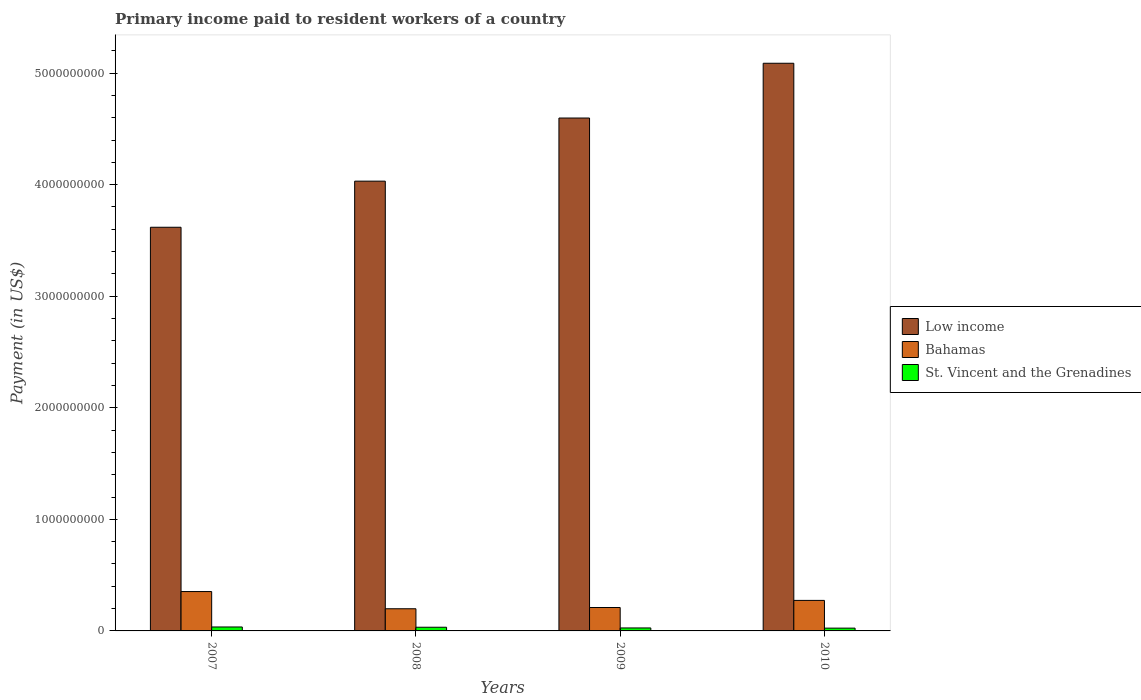How many different coloured bars are there?
Provide a short and direct response. 3. Are the number of bars per tick equal to the number of legend labels?
Your answer should be compact. Yes. Are the number of bars on each tick of the X-axis equal?
Provide a short and direct response. Yes. How many bars are there on the 4th tick from the left?
Provide a succinct answer. 3. What is the label of the 4th group of bars from the left?
Ensure brevity in your answer.  2010. In how many cases, is the number of bars for a given year not equal to the number of legend labels?
Provide a succinct answer. 0. What is the amount paid to workers in Low income in 2008?
Offer a terse response. 4.03e+09. Across all years, what is the maximum amount paid to workers in Low income?
Make the answer very short. 5.09e+09. Across all years, what is the minimum amount paid to workers in Bahamas?
Offer a terse response. 1.99e+08. In which year was the amount paid to workers in Bahamas maximum?
Provide a short and direct response. 2007. What is the total amount paid to workers in Bahamas in the graph?
Provide a short and direct response. 1.04e+09. What is the difference between the amount paid to workers in Bahamas in 2007 and that in 2010?
Your answer should be compact. 7.92e+07. What is the difference between the amount paid to workers in Bahamas in 2007 and the amount paid to workers in Low income in 2010?
Provide a succinct answer. -4.74e+09. What is the average amount paid to workers in St. Vincent and the Grenadines per year?
Keep it short and to the point. 3.00e+07. In the year 2009, what is the difference between the amount paid to workers in St. Vincent and the Grenadines and amount paid to workers in Bahamas?
Provide a succinct answer. -1.83e+08. In how many years, is the amount paid to workers in St. Vincent and the Grenadines greater than 1600000000 US$?
Provide a short and direct response. 0. What is the ratio of the amount paid to workers in St. Vincent and the Grenadines in 2007 to that in 2010?
Your response must be concise. 1.42. Is the difference between the amount paid to workers in St. Vincent and the Grenadines in 2007 and 2008 greater than the difference between the amount paid to workers in Bahamas in 2007 and 2008?
Give a very brief answer. No. What is the difference between the highest and the second highest amount paid to workers in Low income?
Offer a terse response. 4.91e+08. What is the difference between the highest and the lowest amount paid to workers in St. Vincent and the Grenadines?
Your answer should be compact. 1.05e+07. In how many years, is the amount paid to workers in Low income greater than the average amount paid to workers in Low income taken over all years?
Provide a short and direct response. 2. Is the sum of the amount paid to workers in Bahamas in 2007 and 2008 greater than the maximum amount paid to workers in Low income across all years?
Provide a short and direct response. No. Are all the bars in the graph horizontal?
Provide a short and direct response. No. How many years are there in the graph?
Offer a very short reply. 4. Are the values on the major ticks of Y-axis written in scientific E-notation?
Keep it short and to the point. No. Where does the legend appear in the graph?
Keep it short and to the point. Center right. How many legend labels are there?
Offer a very short reply. 3. What is the title of the graph?
Ensure brevity in your answer.  Primary income paid to resident workers of a country. What is the label or title of the Y-axis?
Offer a terse response. Payment (in US$). What is the Payment (in US$) in Low income in 2007?
Your answer should be very brief. 3.62e+09. What is the Payment (in US$) in Bahamas in 2007?
Give a very brief answer. 3.53e+08. What is the Payment (in US$) in St. Vincent and the Grenadines in 2007?
Offer a terse response. 3.54e+07. What is the Payment (in US$) in Low income in 2008?
Offer a very short reply. 4.03e+09. What is the Payment (in US$) in Bahamas in 2008?
Provide a succinct answer. 1.99e+08. What is the Payment (in US$) of St. Vincent and the Grenadines in 2008?
Provide a short and direct response. 3.30e+07. What is the Payment (in US$) of Low income in 2009?
Ensure brevity in your answer.  4.60e+09. What is the Payment (in US$) in Bahamas in 2009?
Your response must be concise. 2.10e+08. What is the Payment (in US$) of St. Vincent and the Grenadines in 2009?
Your answer should be compact. 2.67e+07. What is the Payment (in US$) in Low income in 2010?
Provide a succinct answer. 5.09e+09. What is the Payment (in US$) of Bahamas in 2010?
Provide a succinct answer. 2.74e+08. What is the Payment (in US$) of St. Vincent and the Grenadines in 2010?
Your answer should be very brief. 2.49e+07. Across all years, what is the maximum Payment (in US$) in Low income?
Your answer should be very brief. 5.09e+09. Across all years, what is the maximum Payment (in US$) of Bahamas?
Your response must be concise. 3.53e+08. Across all years, what is the maximum Payment (in US$) in St. Vincent and the Grenadines?
Make the answer very short. 3.54e+07. Across all years, what is the minimum Payment (in US$) of Low income?
Your response must be concise. 3.62e+09. Across all years, what is the minimum Payment (in US$) in Bahamas?
Provide a succinct answer. 1.99e+08. Across all years, what is the minimum Payment (in US$) of St. Vincent and the Grenadines?
Give a very brief answer. 2.49e+07. What is the total Payment (in US$) of Low income in the graph?
Make the answer very short. 1.73e+1. What is the total Payment (in US$) of Bahamas in the graph?
Ensure brevity in your answer.  1.04e+09. What is the total Payment (in US$) in St. Vincent and the Grenadines in the graph?
Provide a succinct answer. 1.20e+08. What is the difference between the Payment (in US$) in Low income in 2007 and that in 2008?
Ensure brevity in your answer.  -4.13e+08. What is the difference between the Payment (in US$) of Bahamas in 2007 and that in 2008?
Make the answer very short. 1.54e+08. What is the difference between the Payment (in US$) of St. Vincent and the Grenadines in 2007 and that in 2008?
Give a very brief answer. 2.46e+06. What is the difference between the Payment (in US$) of Low income in 2007 and that in 2009?
Give a very brief answer. -9.79e+08. What is the difference between the Payment (in US$) in Bahamas in 2007 and that in 2009?
Provide a succinct answer. 1.43e+08. What is the difference between the Payment (in US$) of St. Vincent and the Grenadines in 2007 and that in 2009?
Your answer should be very brief. 8.72e+06. What is the difference between the Payment (in US$) in Low income in 2007 and that in 2010?
Offer a terse response. -1.47e+09. What is the difference between the Payment (in US$) of Bahamas in 2007 and that in 2010?
Your answer should be very brief. 7.92e+07. What is the difference between the Payment (in US$) in St. Vincent and the Grenadines in 2007 and that in 2010?
Offer a terse response. 1.05e+07. What is the difference between the Payment (in US$) in Low income in 2008 and that in 2009?
Give a very brief answer. -5.66e+08. What is the difference between the Payment (in US$) in Bahamas in 2008 and that in 2009?
Keep it short and to the point. -1.12e+07. What is the difference between the Payment (in US$) of St. Vincent and the Grenadines in 2008 and that in 2009?
Your answer should be very brief. 6.26e+06. What is the difference between the Payment (in US$) in Low income in 2008 and that in 2010?
Give a very brief answer. -1.06e+09. What is the difference between the Payment (in US$) in Bahamas in 2008 and that in 2010?
Provide a succinct answer. -7.50e+07. What is the difference between the Payment (in US$) in St. Vincent and the Grenadines in 2008 and that in 2010?
Provide a succinct answer. 8.01e+06. What is the difference between the Payment (in US$) in Low income in 2009 and that in 2010?
Your response must be concise. -4.91e+08. What is the difference between the Payment (in US$) in Bahamas in 2009 and that in 2010?
Give a very brief answer. -6.38e+07. What is the difference between the Payment (in US$) in St. Vincent and the Grenadines in 2009 and that in 2010?
Offer a terse response. 1.75e+06. What is the difference between the Payment (in US$) of Low income in 2007 and the Payment (in US$) of Bahamas in 2008?
Provide a succinct answer. 3.42e+09. What is the difference between the Payment (in US$) of Low income in 2007 and the Payment (in US$) of St. Vincent and the Grenadines in 2008?
Offer a terse response. 3.59e+09. What is the difference between the Payment (in US$) in Bahamas in 2007 and the Payment (in US$) in St. Vincent and the Grenadines in 2008?
Make the answer very short. 3.20e+08. What is the difference between the Payment (in US$) of Low income in 2007 and the Payment (in US$) of Bahamas in 2009?
Offer a very short reply. 3.41e+09. What is the difference between the Payment (in US$) of Low income in 2007 and the Payment (in US$) of St. Vincent and the Grenadines in 2009?
Ensure brevity in your answer.  3.59e+09. What is the difference between the Payment (in US$) in Bahamas in 2007 and the Payment (in US$) in St. Vincent and the Grenadines in 2009?
Ensure brevity in your answer.  3.26e+08. What is the difference between the Payment (in US$) in Low income in 2007 and the Payment (in US$) in Bahamas in 2010?
Keep it short and to the point. 3.34e+09. What is the difference between the Payment (in US$) of Low income in 2007 and the Payment (in US$) of St. Vincent and the Grenadines in 2010?
Offer a very short reply. 3.59e+09. What is the difference between the Payment (in US$) in Bahamas in 2007 and the Payment (in US$) in St. Vincent and the Grenadines in 2010?
Provide a short and direct response. 3.28e+08. What is the difference between the Payment (in US$) of Low income in 2008 and the Payment (in US$) of Bahamas in 2009?
Your answer should be compact. 3.82e+09. What is the difference between the Payment (in US$) of Low income in 2008 and the Payment (in US$) of St. Vincent and the Grenadines in 2009?
Keep it short and to the point. 4.00e+09. What is the difference between the Payment (in US$) in Bahamas in 2008 and the Payment (in US$) in St. Vincent and the Grenadines in 2009?
Offer a terse response. 1.72e+08. What is the difference between the Payment (in US$) in Low income in 2008 and the Payment (in US$) in Bahamas in 2010?
Make the answer very short. 3.76e+09. What is the difference between the Payment (in US$) in Low income in 2008 and the Payment (in US$) in St. Vincent and the Grenadines in 2010?
Keep it short and to the point. 4.01e+09. What is the difference between the Payment (in US$) of Bahamas in 2008 and the Payment (in US$) of St. Vincent and the Grenadines in 2010?
Your response must be concise. 1.74e+08. What is the difference between the Payment (in US$) of Low income in 2009 and the Payment (in US$) of Bahamas in 2010?
Offer a terse response. 4.32e+09. What is the difference between the Payment (in US$) of Low income in 2009 and the Payment (in US$) of St. Vincent and the Grenadines in 2010?
Your response must be concise. 4.57e+09. What is the difference between the Payment (in US$) in Bahamas in 2009 and the Payment (in US$) in St. Vincent and the Grenadines in 2010?
Keep it short and to the point. 1.85e+08. What is the average Payment (in US$) of Low income per year?
Your response must be concise. 4.33e+09. What is the average Payment (in US$) of Bahamas per year?
Your answer should be very brief. 2.59e+08. What is the average Payment (in US$) of St. Vincent and the Grenadines per year?
Your answer should be very brief. 3.00e+07. In the year 2007, what is the difference between the Payment (in US$) of Low income and Payment (in US$) of Bahamas?
Your answer should be compact. 3.27e+09. In the year 2007, what is the difference between the Payment (in US$) of Low income and Payment (in US$) of St. Vincent and the Grenadines?
Offer a very short reply. 3.58e+09. In the year 2007, what is the difference between the Payment (in US$) of Bahamas and Payment (in US$) of St. Vincent and the Grenadines?
Provide a succinct answer. 3.17e+08. In the year 2008, what is the difference between the Payment (in US$) of Low income and Payment (in US$) of Bahamas?
Make the answer very short. 3.83e+09. In the year 2008, what is the difference between the Payment (in US$) in Low income and Payment (in US$) in St. Vincent and the Grenadines?
Your answer should be very brief. 4.00e+09. In the year 2008, what is the difference between the Payment (in US$) in Bahamas and Payment (in US$) in St. Vincent and the Grenadines?
Keep it short and to the point. 1.66e+08. In the year 2009, what is the difference between the Payment (in US$) in Low income and Payment (in US$) in Bahamas?
Ensure brevity in your answer.  4.39e+09. In the year 2009, what is the difference between the Payment (in US$) of Low income and Payment (in US$) of St. Vincent and the Grenadines?
Provide a succinct answer. 4.57e+09. In the year 2009, what is the difference between the Payment (in US$) of Bahamas and Payment (in US$) of St. Vincent and the Grenadines?
Make the answer very short. 1.83e+08. In the year 2010, what is the difference between the Payment (in US$) in Low income and Payment (in US$) in Bahamas?
Keep it short and to the point. 4.81e+09. In the year 2010, what is the difference between the Payment (in US$) of Low income and Payment (in US$) of St. Vincent and the Grenadines?
Your answer should be compact. 5.06e+09. In the year 2010, what is the difference between the Payment (in US$) of Bahamas and Payment (in US$) of St. Vincent and the Grenadines?
Give a very brief answer. 2.49e+08. What is the ratio of the Payment (in US$) in Low income in 2007 to that in 2008?
Keep it short and to the point. 0.9. What is the ratio of the Payment (in US$) in Bahamas in 2007 to that in 2008?
Offer a very short reply. 1.78. What is the ratio of the Payment (in US$) of St. Vincent and the Grenadines in 2007 to that in 2008?
Your answer should be compact. 1.07. What is the ratio of the Payment (in US$) in Low income in 2007 to that in 2009?
Give a very brief answer. 0.79. What is the ratio of the Payment (in US$) of Bahamas in 2007 to that in 2009?
Ensure brevity in your answer.  1.68. What is the ratio of the Payment (in US$) in St. Vincent and the Grenadines in 2007 to that in 2009?
Keep it short and to the point. 1.33. What is the ratio of the Payment (in US$) in Low income in 2007 to that in 2010?
Provide a short and direct response. 0.71. What is the ratio of the Payment (in US$) of Bahamas in 2007 to that in 2010?
Your response must be concise. 1.29. What is the ratio of the Payment (in US$) of St. Vincent and the Grenadines in 2007 to that in 2010?
Offer a very short reply. 1.42. What is the ratio of the Payment (in US$) in Low income in 2008 to that in 2009?
Offer a very short reply. 0.88. What is the ratio of the Payment (in US$) of Bahamas in 2008 to that in 2009?
Ensure brevity in your answer.  0.95. What is the ratio of the Payment (in US$) of St. Vincent and the Grenadines in 2008 to that in 2009?
Provide a short and direct response. 1.23. What is the ratio of the Payment (in US$) in Low income in 2008 to that in 2010?
Offer a terse response. 0.79. What is the ratio of the Payment (in US$) in Bahamas in 2008 to that in 2010?
Your answer should be very brief. 0.73. What is the ratio of the Payment (in US$) in St. Vincent and the Grenadines in 2008 to that in 2010?
Provide a succinct answer. 1.32. What is the ratio of the Payment (in US$) of Low income in 2009 to that in 2010?
Offer a very short reply. 0.9. What is the ratio of the Payment (in US$) in Bahamas in 2009 to that in 2010?
Your response must be concise. 0.77. What is the ratio of the Payment (in US$) of St. Vincent and the Grenadines in 2009 to that in 2010?
Your answer should be compact. 1.07. What is the difference between the highest and the second highest Payment (in US$) in Low income?
Your answer should be compact. 4.91e+08. What is the difference between the highest and the second highest Payment (in US$) of Bahamas?
Keep it short and to the point. 7.92e+07. What is the difference between the highest and the second highest Payment (in US$) in St. Vincent and the Grenadines?
Provide a short and direct response. 2.46e+06. What is the difference between the highest and the lowest Payment (in US$) of Low income?
Give a very brief answer. 1.47e+09. What is the difference between the highest and the lowest Payment (in US$) in Bahamas?
Keep it short and to the point. 1.54e+08. What is the difference between the highest and the lowest Payment (in US$) of St. Vincent and the Grenadines?
Provide a short and direct response. 1.05e+07. 